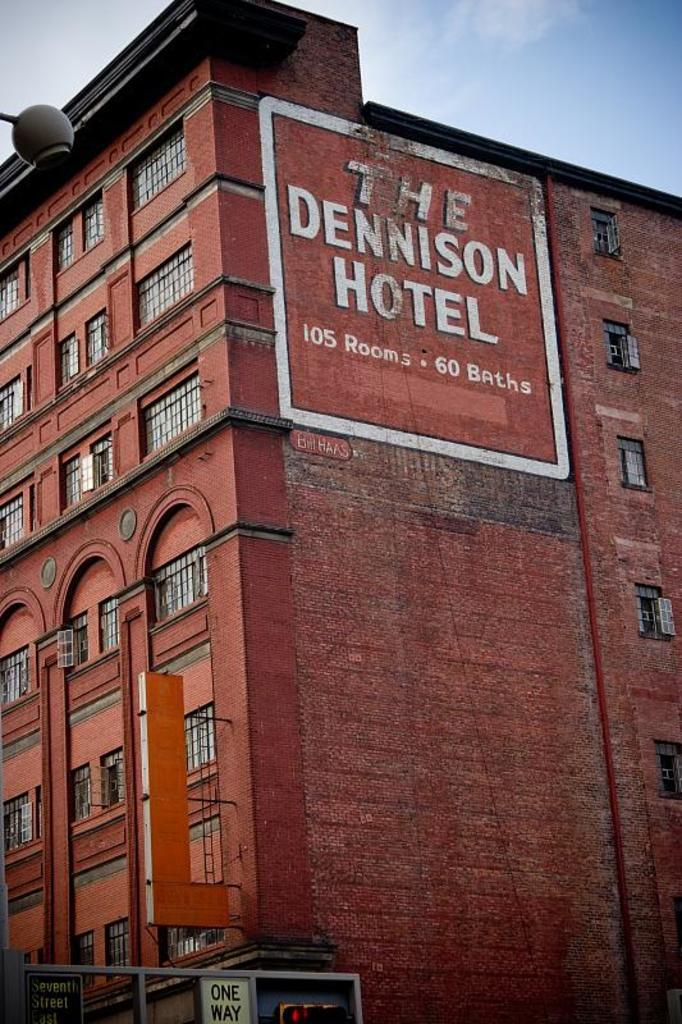What type of structure is present in the image? There is a building in the image. What can be seen attached to the building? There are boards and a traffic signal attached to the building. Can you describe the object in the image? There is an object in the image, but its specific nature is not clear from the provided facts. What is written on a wall in the image? There is writing on a wall in the image. What is visible in the background of the image? There is sky visible in the background of the image, with clouds present. How many tomatoes are hanging from the traffic signal in the image? There are no tomatoes present in the image, and therefore none are hanging from the traffic signal. What type of force is being applied to the building in the image? There is no indication of any force being applied to the building in the image. 